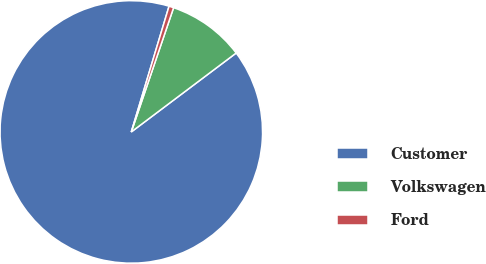<chart> <loc_0><loc_0><loc_500><loc_500><pie_chart><fcel>Customer<fcel>Volkswagen<fcel>Ford<nl><fcel>89.91%<fcel>9.51%<fcel>0.58%<nl></chart> 